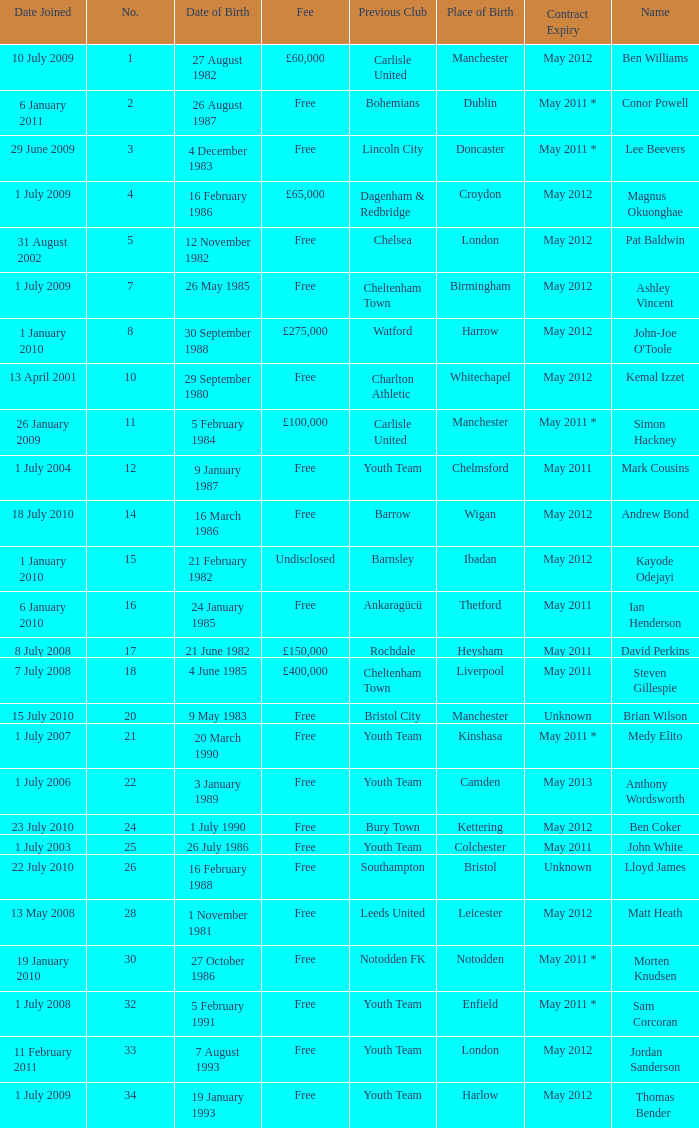For the ben williams name what was the previous club Carlisle United. 